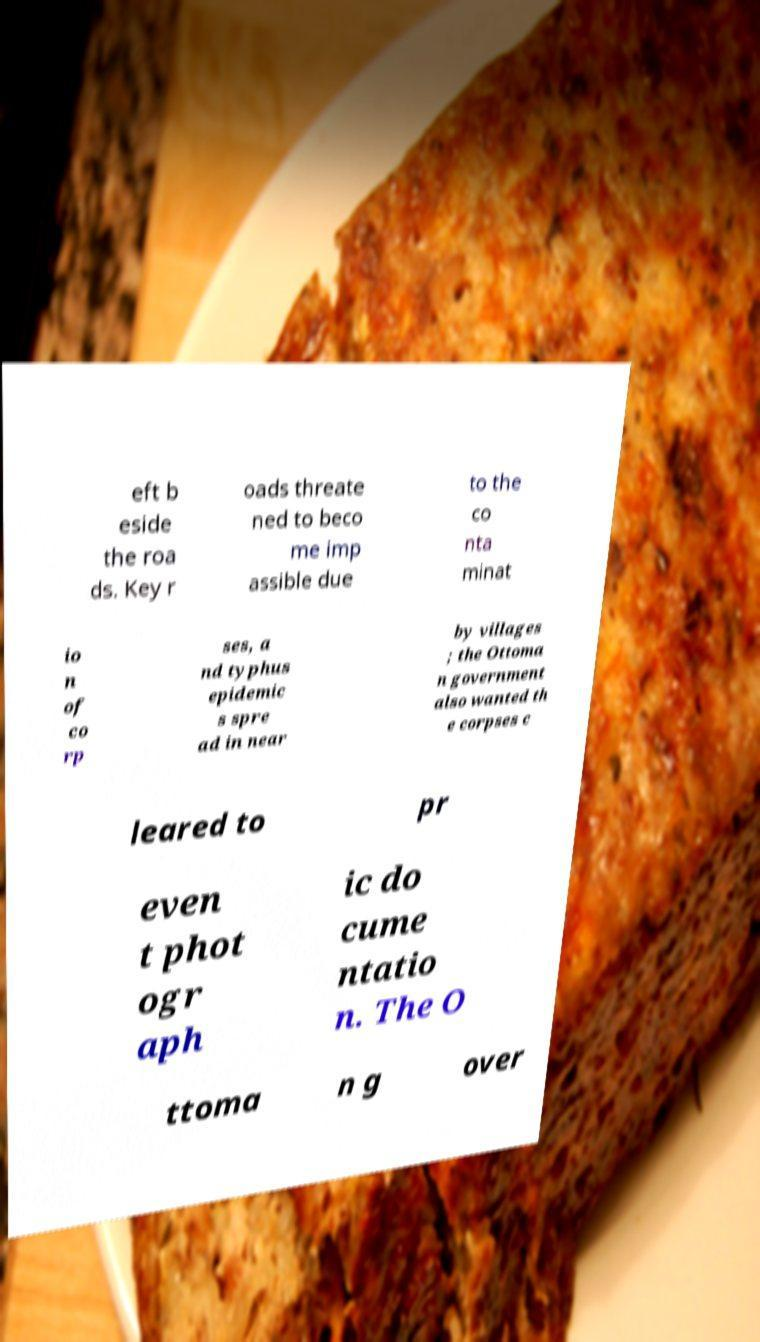For documentation purposes, I need the text within this image transcribed. Could you provide that? eft b eside the roa ds. Key r oads threate ned to beco me imp assible due to the co nta minat io n of co rp ses, a nd typhus epidemic s spre ad in near by villages ; the Ottoma n government also wanted th e corpses c leared to pr even t phot ogr aph ic do cume ntatio n. The O ttoma n g over 